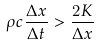Convert formula to latex. <formula><loc_0><loc_0><loc_500><loc_500>\rho c \frac { \Delta x } { \Delta t } > \frac { 2 K } { \Delta x }</formula> 